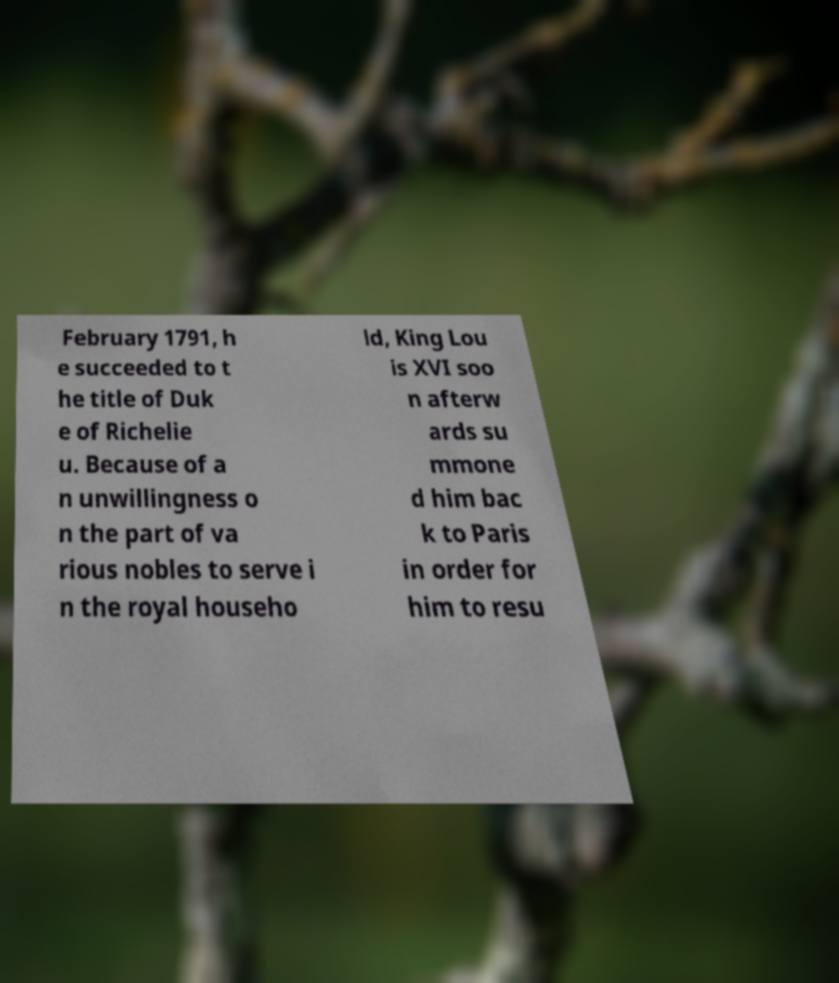Can you accurately transcribe the text from the provided image for me? February 1791, h e succeeded to t he title of Duk e of Richelie u. Because of a n unwillingness o n the part of va rious nobles to serve i n the royal househo ld, King Lou is XVI soo n afterw ards su mmone d him bac k to Paris in order for him to resu 